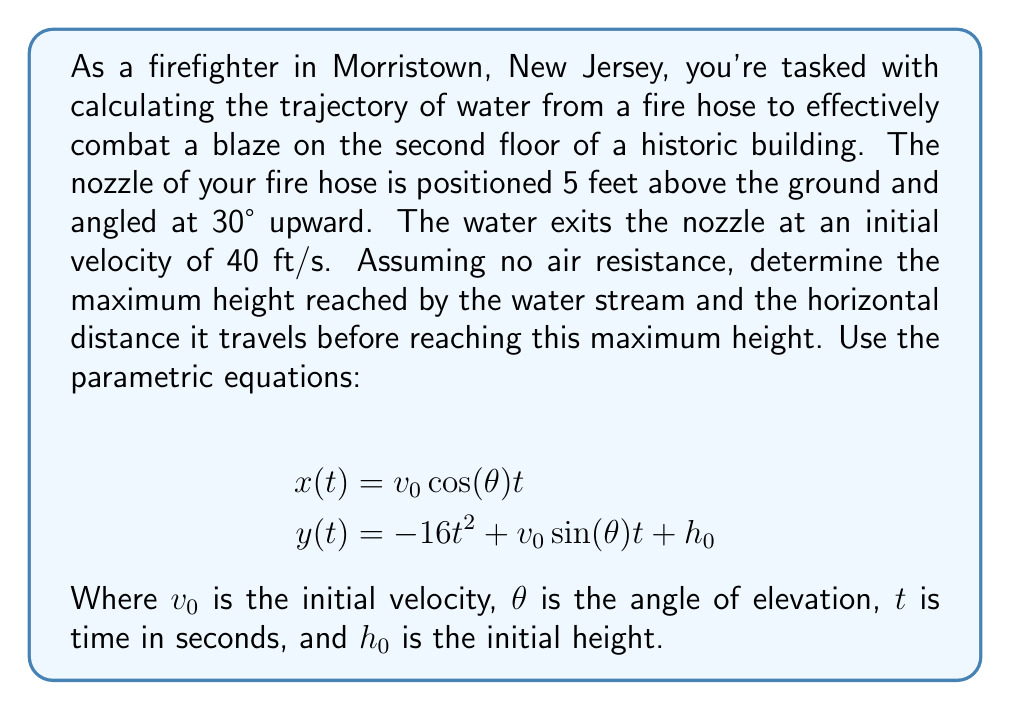Could you help me with this problem? Let's approach this problem step by step:

1) First, let's identify our known values:
   $v_0 = 40$ ft/s
   $\theta = 30°$
   $h_0 = 5$ ft
   $g = 32$ ft/s² (acceleration due to gravity)

2) To find the maximum height, we need to determine when the vertical velocity is zero. The vertical velocity is given by:

   $v_y(t) = \frac{dy}{dt} = -32t + v_0 \sin(\theta)$

3) Set this equal to zero and solve for t:
   
   $0 = -32t + 40 \sin(30°)$
   $32t = 40 \sin(30°) = 40 \cdot 0.5 = 20$
   $t = \frac{20}{32} = 0.625$ seconds

4) Now we can find the maximum height by plugging this time into the y equation:

   $y(0.625) = -16(0.625)^2 + 40 \sin(30°)(0.625) + 5$
   $= -6.25 + 12.5 + 5 = 11.25$ feet

5) To find the horizontal distance at this point, we use the x equation:

   $x(0.625) = 40 \cos(30°)(0.625)$
   $= 40 \cdot 0.866 \cdot 0.625 = 21.65$ feet

Therefore, the water reaches a maximum height of 11.25 feet above the ground (6.25 feet above the nozzle) at a horizontal distance of 21.65 feet from the nozzle.
Answer: Maximum height: 11.25 feet
Horizontal distance at maximum height: 21.65 feet 